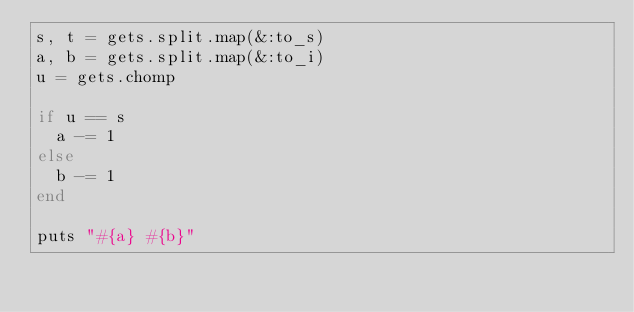Convert code to text. <code><loc_0><loc_0><loc_500><loc_500><_Ruby_>s, t = gets.split.map(&:to_s)
a, b = gets.split.map(&:to_i)
u = gets.chomp

if u == s
  a -= 1
else
  b -= 1
end

puts "#{a} #{b}"</code> 